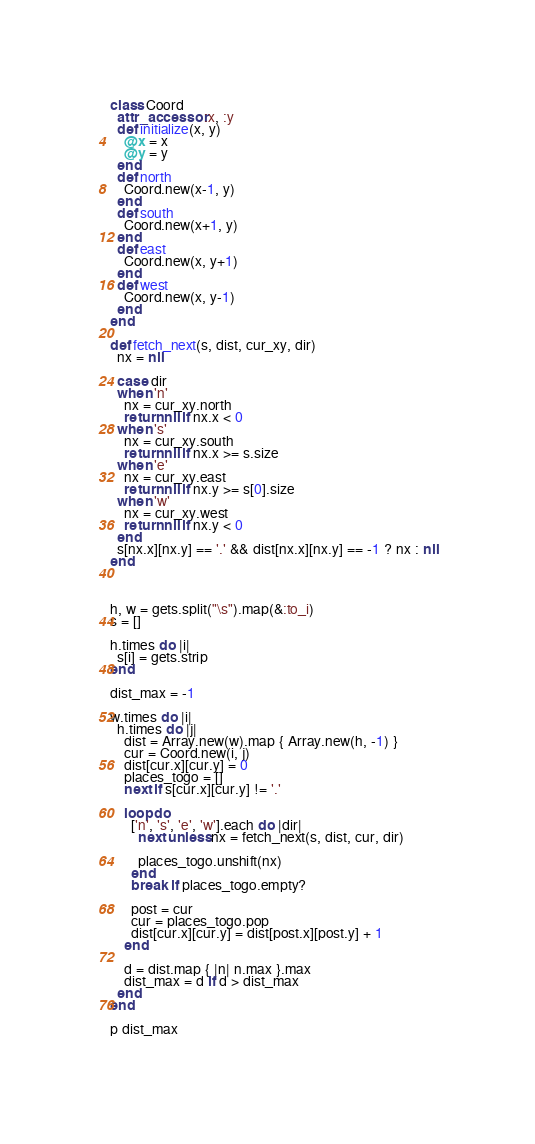<code> <loc_0><loc_0><loc_500><loc_500><_Ruby_>class Coord
  attr_accessor :x, :y
  def initialize(x, y)
    @x = x
    @y = y
  end
  def north 
    Coord.new(x-1, y)
  end
  def south
    Coord.new(x+1, y)
  end
  def east
    Coord.new(x, y+1)
  end
  def west
    Coord.new(x, y-1)
  end
end

def fetch_next(s, dist, cur_xy, dir)
  nx = nil

  case dir
  when 'n'
    nx = cur_xy.north
    return nil if nx.x < 0
  when 's'
    nx = cur_xy.south
    return nil if nx.x >= s.size
  when 'e'
    nx = cur_xy.east
    return nil if nx.y >= s[0].size
  when 'w'
    nx = cur_xy.west
    return nil if nx.y < 0
  end
  s[nx.x][nx.y] == '.' && dist[nx.x][nx.y] == -1 ? nx : nil
end
    
    

h, w = gets.split("\s").map(&:to_i)
s = []

h.times do |i|
  s[i] = gets.strip
end

dist_max = -1

w.times do |i|
  h.times do |j|
    dist = Array.new(w).map { Array.new(h, -1) }
    cur = Coord.new(i, j)
    dist[cur.x][cur.y] = 0
    places_togo = []
    next if s[cur.x][cur.y] != '.'
    
    loop do
      ['n', 's', 'e', 'w'].each do |dir|
        next unless nx = fetch_next(s, dist, cur, dir)
        
        places_togo.unshift(nx)
      end
      break if places_togo.empty?
      
      post = cur
      cur = places_togo.pop
      dist[cur.x][cur.y] = dist[post.x][post.y] + 1
    end
    
    d = dist.map { |n| n.max }.max
    dist_max = d if d > dist_max
  end
end

p dist_max
  </code> 